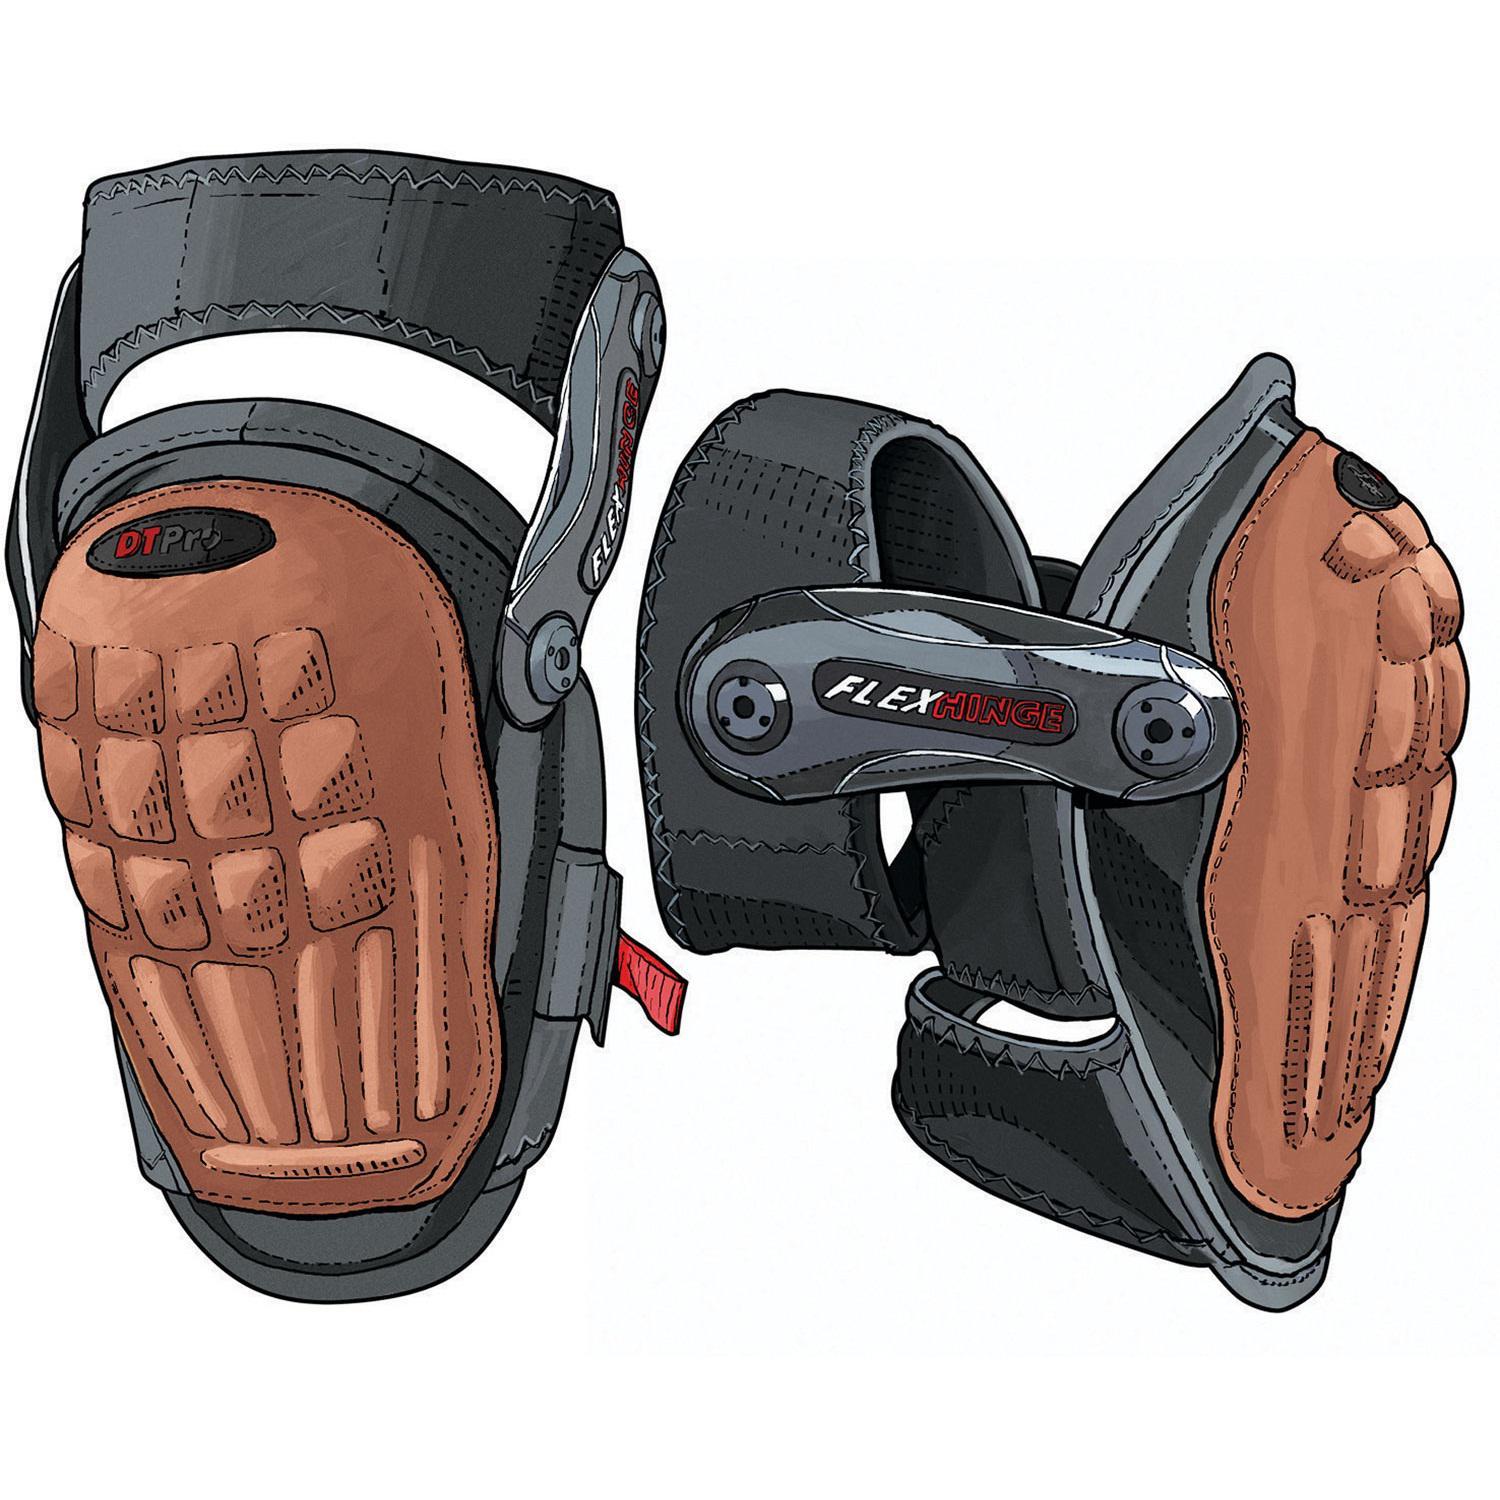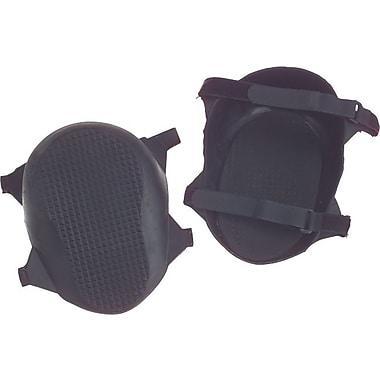The first image is the image on the left, the second image is the image on the right. Examine the images to the left and right. Is the description "The kneepads on the left are brown and black, and the pair on the right are solid black." accurate? Answer yes or no. Yes. The first image is the image on the left, the second image is the image on the right. Examine the images to the left and right. Is the description "There are two charcoal colored knee pads with similar colored straps in the image on the right." accurate? Answer yes or no. Yes. 